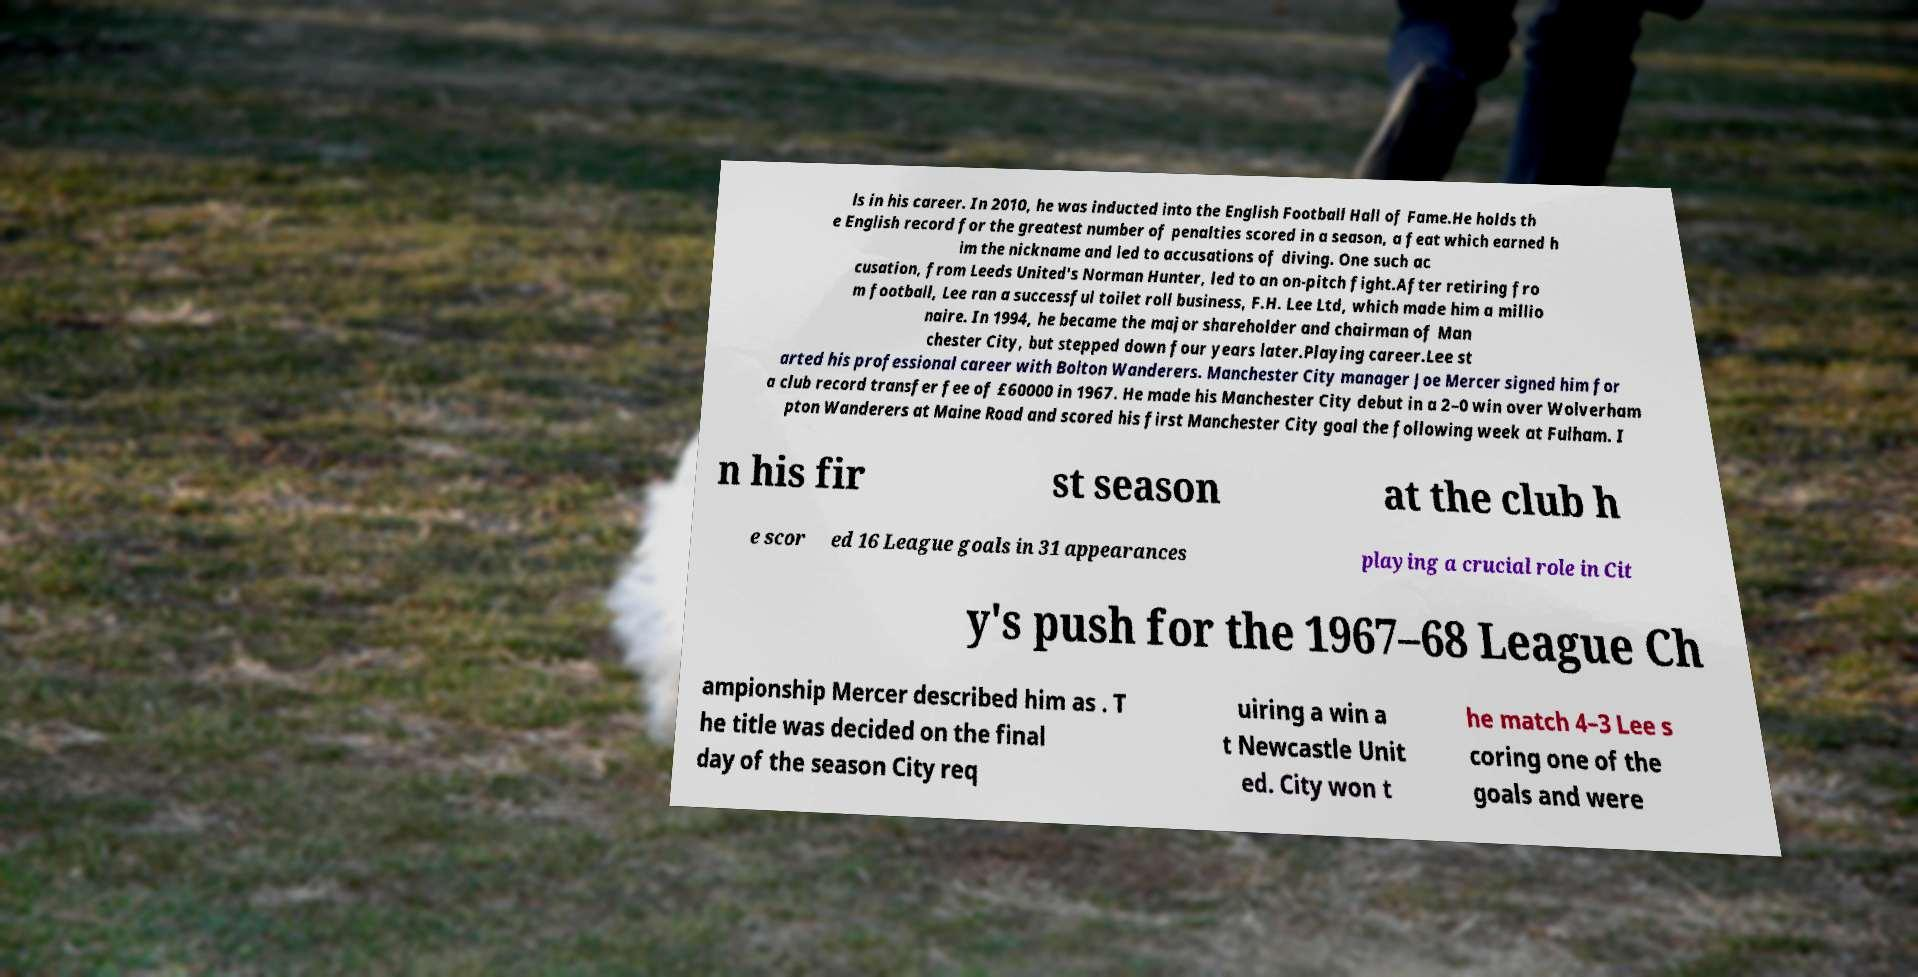For documentation purposes, I need the text within this image transcribed. Could you provide that? ls in his career. In 2010, he was inducted into the English Football Hall of Fame.He holds th e English record for the greatest number of penalties scored in a season, a feat which earned h im the nickname and led to accusations of diving. One such ac cusation, from Leeds United's Norman Hunter, led to an on-pitch fight.After retiring fro m football, Lee ran a successful toilet roll business, F.H. Lee Ltd, which made him a millio naire. In 1994, he became the major shareholder and chairman of Man chester City, but stepped down four years later.Playing career.Lee st arted his professional career with Bolton Wanderers. Manchester City manager Joe Mercer signed him for a club record transfer fee of £60000 in 1967. He made his Manchester City debut in a 2–0 win over Wolverham pton Wanderers at Maine Road and scored his first Manchester City goal the following week at Fulham. I n his fir st season at the club h e scor ed 16 League goals in 31 appearances playing a crucial role in Cit y's push for the 1967–68 League Ch ampionship Mercer described him as . T he title was decided on the final day of the season City req uiring a win a t Newcastle Unit ed. City won t he match 4–3 Lee s coring one of the goals and were 